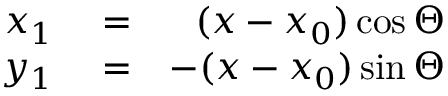Convert formula to latex. <formula><loc_0><loc_0><loc_500><loc_500>\begin{array} { r l r } { x _ { 1 } } & = } & { ( x - x _ { 0 } ) \cos \Theta } \\ { y _ { 1 } } & = } & { - ( x - x _ { 0 } ) \sin \Theta } \end{array}</formula> 